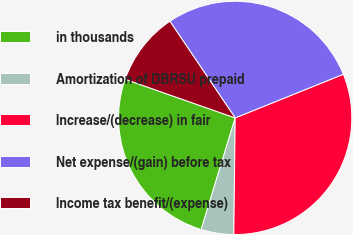<chart> <loc_0><loc_0><loc_500><loc_500><pie_chart><fcel>in thousands<fcel>Amortization of DBRSU prepaid<fcel>Increase/(decrease) in fair<fcel>Net expense/(gain) before tax<fcel>Income tax benefit/(expense)<nl><fcel>25.67%<fcel>4.52%<fcel>31.29%<fcel>28.35%<fcel>10.17%<nl></chart> 